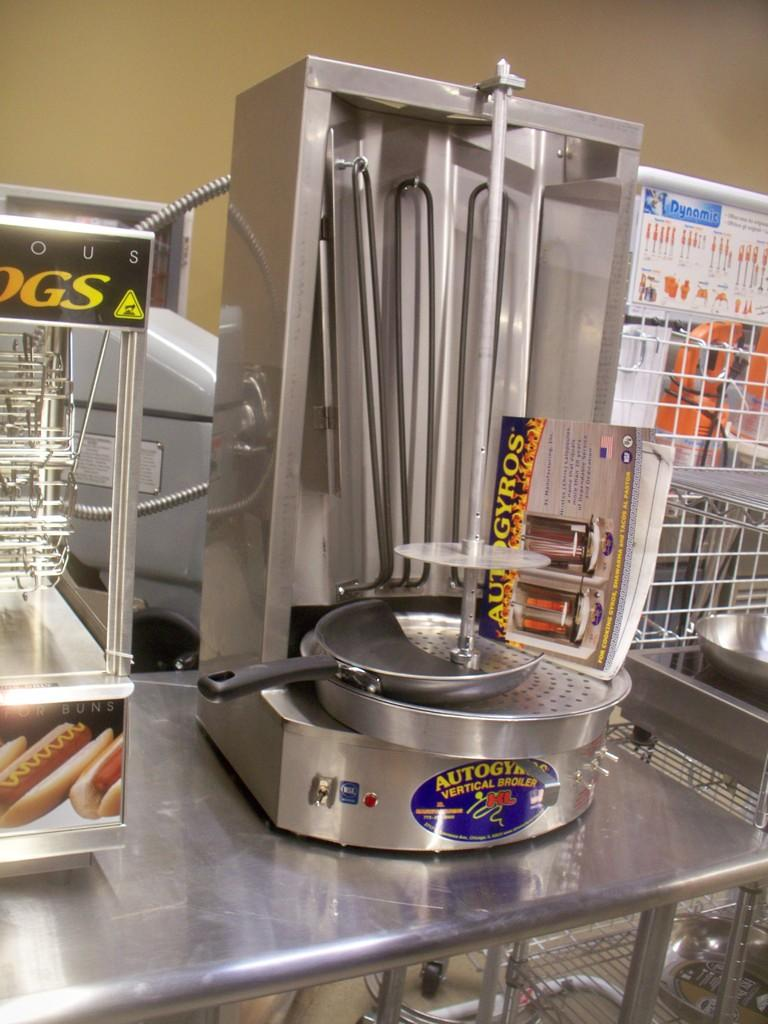<image>
Relay a brief, clear account of the picture shown. A vertical broiler is on a counter next to a hot dog warmer. 